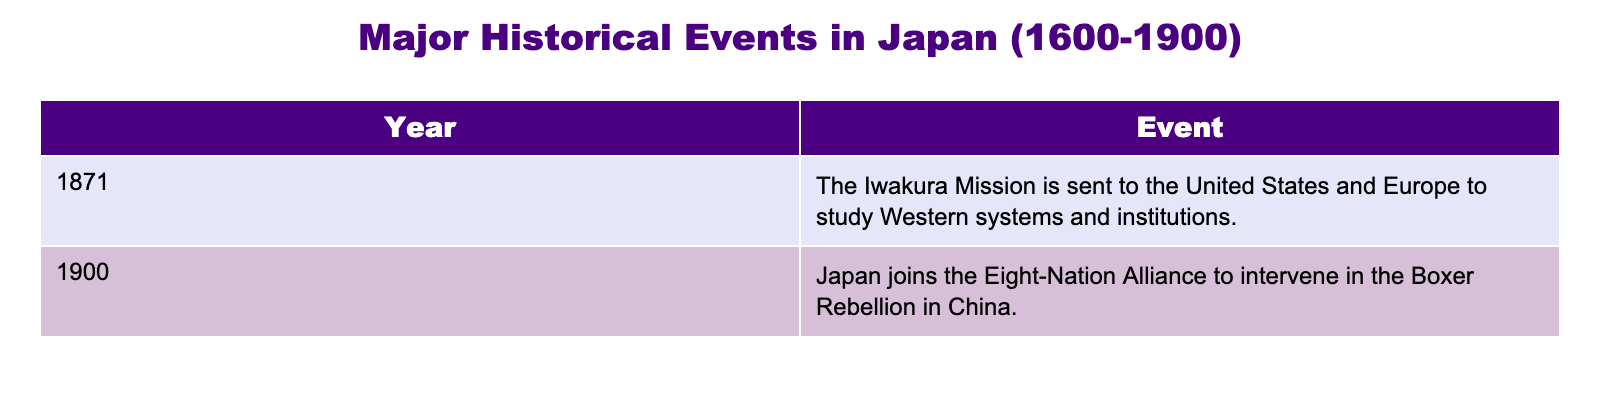What event occurred in Japan in 1871? According to the table, the event that occurred in Japan in 1871 was the Iwakura Mission being sent to the United States and Europe to study Western systems and institutions.
Answer: The Iwakura Mission What year did Japan join the Eight-Nation Alliance? The table indicates that Japan joined the Eight-Nation Alliance in the year 1900.
Answer: 1900 Which event happened later: the Iwakura Mission or Japan joining the Eight-Nation Alliance? The Iwakura Mission occurred in 1871 and Japan joined the Eight-Nation Alliance in 1900. Since 1900 is later than 1871, Japan joining the alliance happened later.
Answer: Japan joining the Eight-Nation Alliance Is it true that Japan was involved in the Boxer Rebellion? The table shows that Japan joined the Eight-Nation Alliance to intervene in the Boxer Rebellion in China, which confirms that Japan was indeed involved in it.
Answer: Yes What is the time gap between the Iwakura Mission and Japan joining the Eight-Nation Alliance? To find the time gap, subtract the year of the Iwakura Mission (1871) from the year Japan joined the Eight-Nation Alliance (1900): 1900 - 1871 = 29. Therefore, there is a 29-year gap between the two events.
Answer: 29 years 